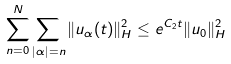Convert formula to latex. <formula><loc_0><loc_0><loc_500><loc_500>\sum _ { n = 0 } ^ { N } \sum _ { | \alpha | = n } \| u _ { \alpha } ( t ) \| _ { H } ^ { 2 } \leq e ^ { C _ { 2 } t } \| u _ { 0 } \| _ { H } ^ { 2 }</formula> 